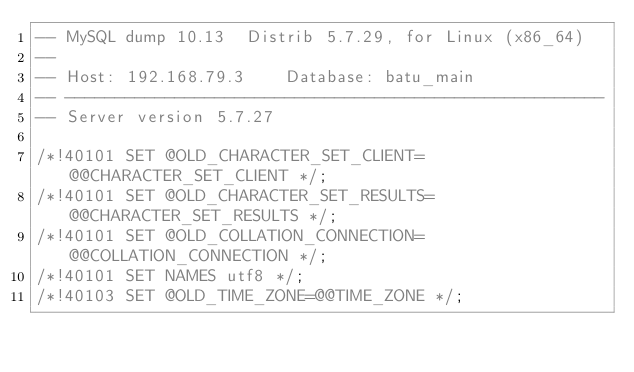<code> <loc_0><loc_0><loc_500><loc_500><_SQL_>-- MySQL dump 10.13  Distrib 5.7.29, for Linux (x86_64)
--
-- Host: 192.168.79.3    Database: batu_main
-- ------------------------------------------------------
-- Server version	5.7.27

/*!40101 SET @OLD_CHARACTER_SET_CLIENT=@@CHARACTER_SET_CLIENT */;
/*!40101 SET @OLD_CHARACTER_SET_RESULTS=@@CHARACTER_SET_RESULTS */;
/*!40101 SET @OLD_COLLATION_CONNECTION=@@COLLATION_CONNECTION */;
/*!40101 SET NAMES utf8 */;
/*!40103 SET @OLD_TIME_ZONE=@@TIME_ZONE */;</code> 